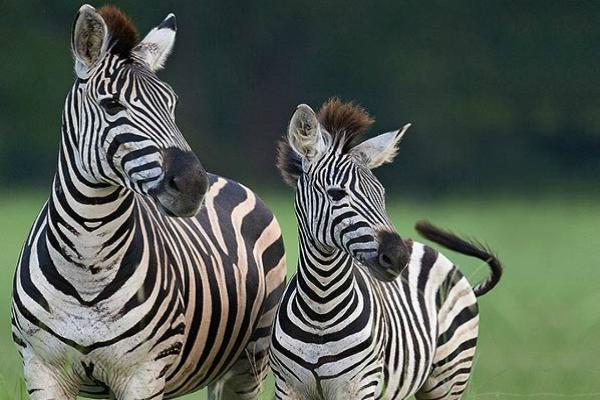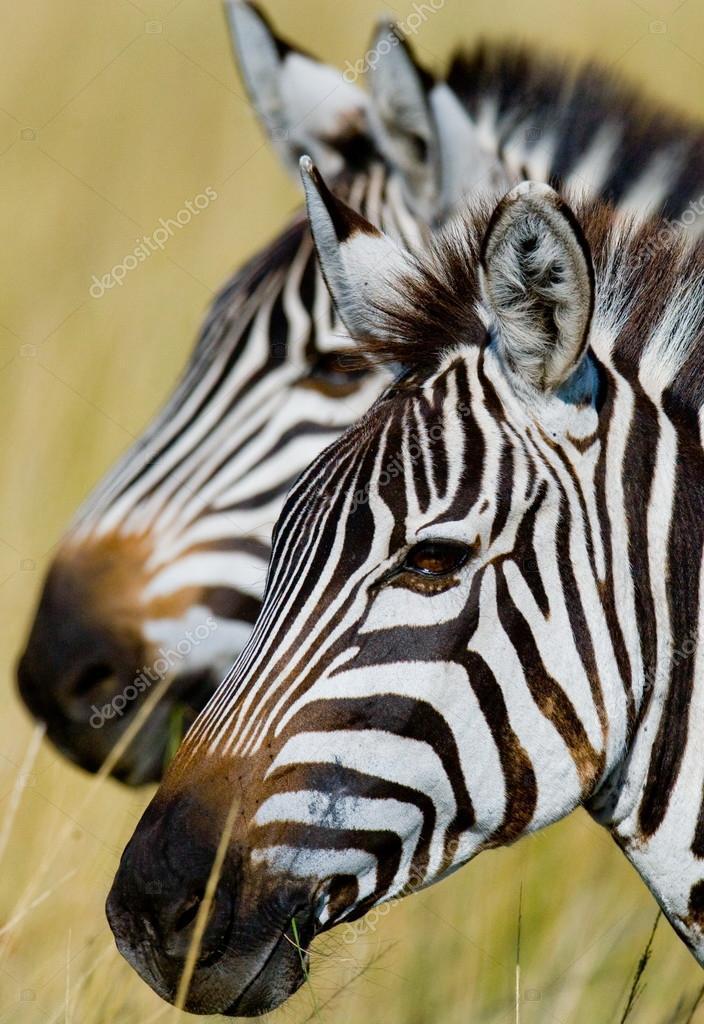The first image is the image on the left, the second image is the image on the right. Assess this claim about the two images: "In one image, one zebra has its head over the back of a zebra with its rear facing the camera and its neck turned so it can look forward.". Correct or not? Answer yes or no. No. The first image is the image on the left, the second image is the image on the right. Given the left and right images, does the statement "in at least one image, there are two black and white striped zebra heads facing left." hold true? Answer yes or no. Yes. 